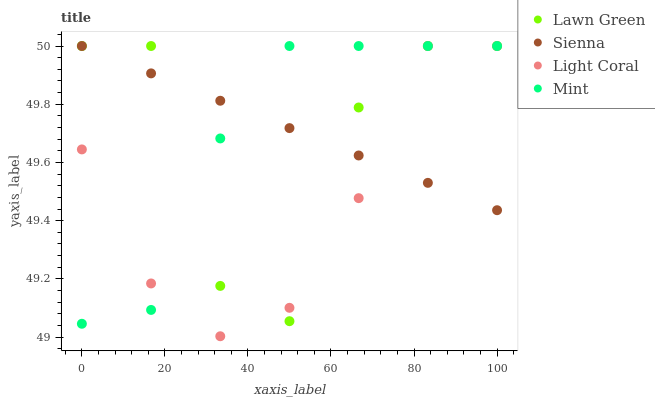Does Light Coral have the minimum area under the curve?
Answer yes or no. Yes. Does Sienna have the maximum area under the curve?
Answer yes or no. Yes. Does Lawn Green have the minimum area under the curve?
Answer yes or no. No. Does Lawn Green have the maximum area under the curve?
Answer yes or no. No. Is Sienna the smoothest?
Answer yes or no. Yes. Is Lawn Green the roughest?
Answer yes or no. Yes. Is Mint the smoothest?
Answer yes or no. No. Is Mint the roughest?
Answer yes or no. No. Does Light Coral have the lowest value?
Answer yes or no. Yes. Does Lawn Green have the lowest value?
Answer yes or no. No. Does Light Coral have the highest value?
Answer yes or no. Yes. Does Sienna intersect Light Coral?
Answer yes or no. Yes. Is Sienna less than Light Coral?
Answer yes or no. No. Is Sienna greater than Light Coral?
Answer yes or no. No. 